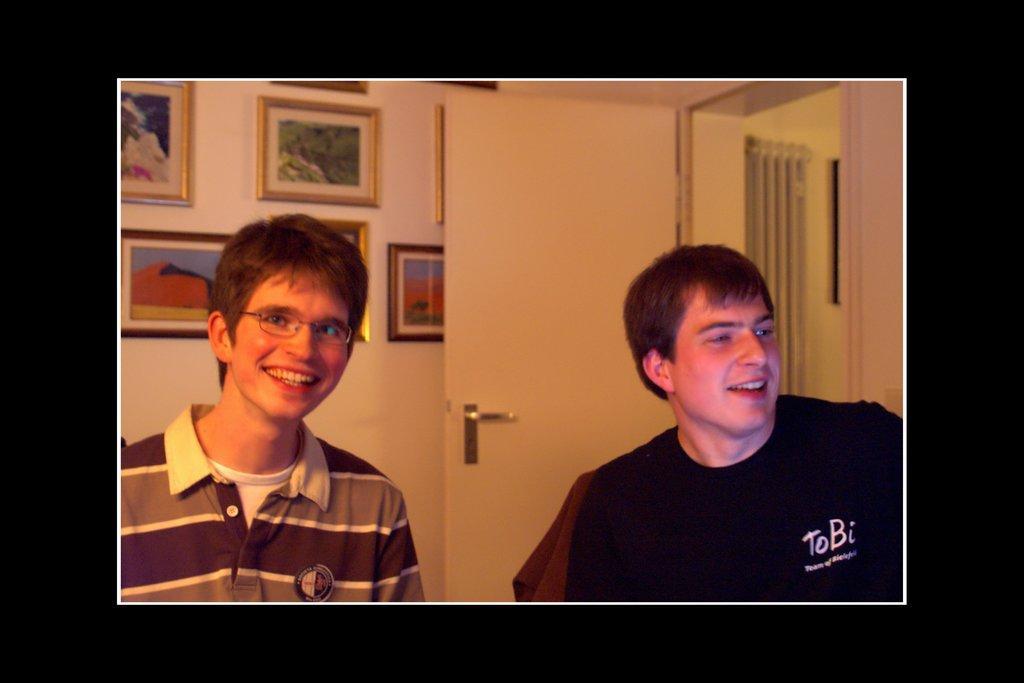In one or two sentences, can you explain what this image depicts? In this image we can see this person wearing black T-shirt and this person wearing T-shirt and spectacles, are smiling. In the background, we can see photo frames on the wall, wooden door and curtains in another room. 